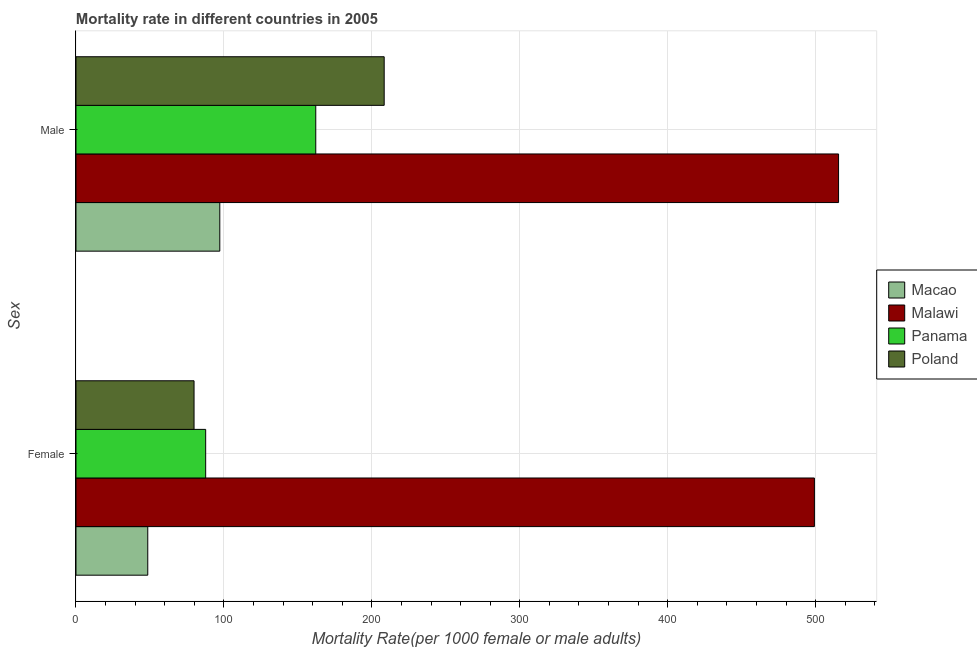How many groups of bars are there?
Your answer should be compact. 2. Are the number of bars on each tick of the Y-axis equal?
Keep it short and to the point. Yes. How many bars are there on the 2nd tick from the top?
Keep it short and to the point. 4. How many bars are there on the 2nd tick from the bottom?
Make the answer very short. 4. What is the female mortality rate in Macao?
Offer a very short reply. 48.51. Across all countries, what is the maximum male mortality rate?
Ensure brevity in your answer.  515.46. Across all countries, what is the minimum male mortality rate?
Your answer should be compact. 97.21. In which country was the male mortality rate maximum?
Your response must be concise. Malawi. In which country was the male mortality rate minimum?
Your answer should be compact. Macao. What is the total female mortality rate in the graph?
Offer a very short reply. 715.1. What is the difference between the female mortality rate in Panama and that in Malawi?
Keep it short and to the point. -411.47. What is the difference between the male mortality rate in Panama and the female mortality rate in Malawi?
Provide a succinct answer. -337.06. What is the average female mortality rate per country?
Ensure brevity in your answer.  178.78. What is the difference between the female mortality rate and male mortality rate in Poland?
Your answer should be very brief. -128.52. In how many countries, is the male mortality rate greater than 380 ?
Give a very brief answer. 1. What is the ratio of the male mortality rate in Macao to that in Panama?
Provide a succinct answer. 0.6. Is the male mortality rate in Malawi less than that in Poland?
Provide a short and direct response. No. In how many countries, is the female mortality rate greater than the average female mortality rate taken over all countries?
Your answer should be very brief. 1. What does the 3rd bar from the top in Male represents?
Ensure brevity in your answer.  Malawi. What does the 3rd bar from the bottom in Male represents?
Give a very brief answer. Panama. How many bars are there?
Give a very brief answer. 8. Are all the bars in the graph horizontal?
Provide a succinct answer. Yes. How many countries are there in the graph?
Your response must be concise. 4. Where does the legend appear in the graph?
Keep it short and to the point. Center right. How are the legend labels stacked?
Provide a short and direct response. Vertical. What is the title of the graph?
Make the answer very short. Mortality rate in different countries in 2005. Does "Haiti" appear as one of the legend labels in the graph?
Keep it short and to the point. No. What is the label or title of the X-axis?
Offer a terse response. Mortality Rate(per 1000 female or male adults). What is the label or title of the Y-axis?
Ensure brevity in your answer.  Sex. What is the Mortality Rate(per 1000 female or male adults) of Macao in Female?
Offer a very short reply. 48.51. What is the Mortality Rate(per 1000 female or male adults) of Malawi in Female?
Give a very brief answer. 499.13. What is the Mortality Rate(per 1000 female or male adults) of Panama in Female?
Give a very brief answer. 87.66. What is the Mortality Rate(per 1000 female or male adults) in Poland in Female?
Make the answer very short. 79.8. What is the Mortality Rate(per 1000 female or male adults) of Macao in Male?
Make the answer very short. 97.21. What is the Mortality Rate(per 1000 female or male adults) of Malawi in Male?
Your answer should be compact. 515.46. What is the Mortality Rate(per 1000 female or male adults) of Panama in Male?
Make the answer very short. 162.07. What is the Mortality Rate(per 1000 female or male adults) of Poland in Male?
Offer a terse response. 208.32. Across all Sex, what is the maximum Mortality Rate(per 1000 female or male adults) in Macao?
Offer a very short reply. 97.21. Across all Sex, what is the maximum Mortality Rate(per 1000 female or male adults) in Malawi?
Offer a very short reply. 515.46. Across all Sex, what is the maximum Mortality Rate(per 1000 female or male adults) in Panama?
Provide a short and direct response. 162.07. Across all Sex, what is the maximum Mortality Rate(per 1000 female or male adults) in Poland?
Offer a very short reply. 208.32. Across all Sex, what is the minimum Mortality Rate(per 1000 female or male adults) of Macao?
Your answer should be very brief. 48.51. Across all Sex, what is the minimum Mortality Rate(per 1000 female or male adults) in Malawi?
Keep it short and to the point. 499.13. Across all Sex, what is the minimum Mortality Rate(per 1000 female or male adults) of Panama?
Offer a terse response. 87.66. Across all Sex, what is the minimum Mortality Rate(per 1000 female or male adults) in Poland?
Provide a succinct answer. 79.8. What is the total Mortality Rate(per 1000 female or male adults) in Macao in the graph?
Ensure brevity in your answer.  145.72. What is the total Mortality Rate(per 1000 female or male adults) in Malawi in the graph?
Provide a short and direct response. 1014.59. What is the total Mortality Rate(per 1000 female or male adults) of Panama in the graph?
Your answer should be compact. 249.73. What is the total Mortality Rate(per 1000 female or male adults) in Poland in the graph?
Keep it short and to the point. 288.12. What is the difference between the Mortality Rate(per 1000 female or male adults) in Macao in Female and that in Male?
Make the answer very short. -48.7. What is the difference between the Mortality Rate(per 1000 female or male adults) of Malawi in Female and that in Male?
Provide a succinct answer. -16.33. What is the difference between the Mortality Rate(per 1000 female or male adults) of Panama in Female and that in Male?
Offer a terse response. -74.41. What is the difference between the Mortality Rate(per 1000 female or male adults) of Poland in Female and that in Male?
Ensure brevity in your answer.  -128.52. What is the difference between the Mortality Rate(per 1000 female or male adults) in Macao in Female and the Mortality Rate(per 1000 female or male adults) in Malawi in Male?
Give a very brief answer. -466.95. What is the difference between the Mortality Rate(per 1000 female or male adults) of Macao in Female and the Mortality Rate(per 1000 female or male adults) of Panama in Male?
Offer a very short reply. -113.56. What is the difference between the Mortality Rate(per 1000 female or male adults) of Macao in Female and the Mortality Rate(per 1000 female or male adults) of Poland in Male?
Make the answer very short. -159.81. What is the difference between the Mortality Rate(per 1000 female or male adults) in Malawi in Female and the Mortality Rate(per 1000 female or male adults) in Panama in Male?
Provide a succinct answer. 337.06. What is the difference between the Mortality Rate(per 1000 female or male adults) in Malawi in Female and the Mortality Rate(per 1000 female or male adults) in Poland in Male?
Your answer should be very brief. 290.81. What is the difference between the Mortality Rate(per 1000 female or male adults) of Panama in Female and the Mortality Rate(per 1000 female or male adults) of Poland in Male?
Your response must be concise. -120.66. What is the average Mortality Rate(per 1000 female or male adults) in Macao per Sex?
Your response must be concise. 72.86. What is the average Mortality Rate(per 1000 female or male adults) of Malawi per Sex?
Keep it short and to the point. 507.3. What is the average Mortality Rate(per 1000 female or male adults) in Panama per Sex?
Your answer should be very brief. 124.87. What is the average Mortality Rate(per 1000 female or male adults) in Poland per Sex?
Provide a short and direct response. 144.06. What is the difference between the Mortality Rate(per 1000 female or male adults) of Macao and Mortality Rate(per 1000 female or male adults) of Malawi in Female?
Give a very brief answer. -450.62. What is the difference between the Mortality Rate(per 1000 female or male adults) in Macao and Mortality Rate(per 1000 female or male adults) in Panama in Female?
Offer a terse response. -39.15. What is the difference between the Mortality Rate(per 1000 female or male adults) of Macao and Mortality Rate(per 1000 female or male adults) of Poland in Female?
Your answer should be compact. -31.28. What is the difference between the Mortality Rate(per 1000 female or male adults) in Malawi and Mortality Rate(per 1000 female or male adults) in Panama in Female?
Make the answer very short. 411.47. What is the difference between the Mortality Rate(per 1000 female or male adults) in Malawi and Mortality Rate(per 1000 female or male adults) in Poland in Female?
Offer a very short reply. 419.34. What is the difference between the Mortality Rate(per 1000 female or male adults) of Panama and Mortality Rate(per 1000 female or male adults) of Poland in Female?
Your response must be concise. 7.86. What is the difference between the Mortality Rate(per 1000 female or male adults) of Macao and Mortality Rate(per 1000 female or male adults) of Malawi in Male?
Provide a succinct answer. -418.25. What is the difference between the Mortality Rate(per 1000 female or male adults) of Macao and Mortality Rate(per 1000 female or male adults) of Panama in Male?
Keep it short and to the point. -64.86. What is the difference between the Mortality Rate(per 1000 female or male adults) of Macao and Mortality Rate(per 1000 female or male adults) of Poland in Male?
Your answer should be very brief. -111.11. What is the difference between the Mortality Rate(per 1000 female or male adults) in Malawi and Mortality Rate(per 1000 female or male adults) in Panama in Male?
Your answer should be compact. 353.39. What is the difference between the Mortality Rate(per 1000 female or male adults) in Malawi and Mortality Rate(per 1000 female or male adults) in Poland in Male?
Your answer should be very brief. 307.14. What is the difference between the Mortality Rate(per 1000 female or male adults) of Panama and Mortality Rate(per 1000 female or male adults) of Poland in Male?
Provide a short and direct response. -46.25. What is the ratio of the Mortality Rate(per 1000 female or male adults) in Macao in Female to that in Male?
Provide a short and direct response. 0.5. What is the ratio of the Mortality Rate(per 1000 female or male adults) of Malawi in Female to that in Male?
Provide a short and direct response. 0.97. What is the ratio of the Mortality Rate(per 1000 female or male adults) of Panama in Female to that in Male?
Offer a very short reply. 0.54. What is the ratio of the Mortality Rate(per 1000 female or male adults) of Poland in Female to that in Male?
Keep it short and to the point. 0.38. What is the difference between the highest and the second highest Mortality Rate(per 1000 female or male adults) of Macao?
Offer a very short reply. 48.7. What is the difference between the highest and the second highest Mortality Rate(per 1000 female or male adults) in Malawi?
Give a very brief answer. 16.33. What is the difference between the highest and the second highest Mortality Rate(per 1000 female or male adults) of Panama?
Give a very brief answer. 74.41. What is the difference between the highest and the second highest Mortality Rate(per 1000 female or male adults) in Poland?
Make the answer very short. 128.52. What is the difference between the highest and the lowest Mortality Rate(per 1000 female or male adults) of Macao?
Your answer should be compact. 48.7. What is the difference between the highest and the lowest Mortality Rate(per 1000 female or male adults) of Malawi?
Your answer should be compact. 16.33. What is the difference between the highest and the lowest Mortality Rate(per 1000 female or male adults) of Panama?
Make the answer very short. 74.41. What is the difference between the highest and the lowest Mortality Rate(per 1000 female or male adults) in Poland?
Keep it short and to the point. 128.52. 